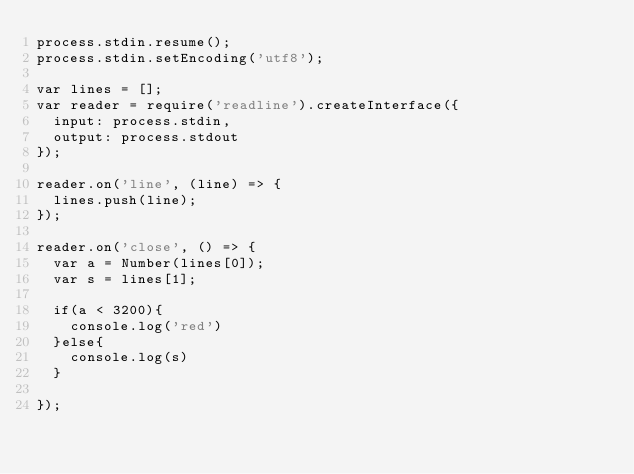Convert code to text. <code><loc_0><loc_0><loc_500><loc_500><_JavaScript_>process.stdin.resume();
process.stdin.setEncoding('utf8');

var lines = [];
var reader = require('readline').createInterface({
  input: process.stdin,
  output: process.stdout
});

reader.on('line', (line) => {
  lines.push(line);
});

reader.on('close', () => {
  var a = Number(lines[0]);
  var s = lines[1];

  if(a < 3200){
    console.log('red')
  }else{
    console.log(s)
  }

});
</code> 